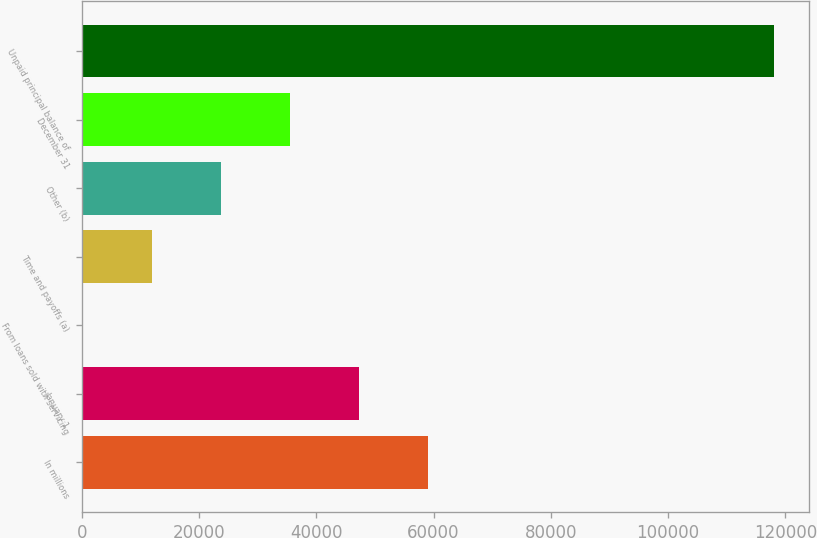<chart> <loc_0><loc_0><loc_500><loc_500><bar_chart><fcel>In millions<fcel>January 1<fcel>From loans sold with servicing<fcel>Time and payoffs (a)<fcel>Other (b)<fcel>December 31<fcel>Unpaid principal balance of<nl><fcel>59088<fcel>47294<fcel>118<fcel>11912<fcel>23706<fcel>35500<fcel>118058<nl></chart> 